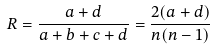Convert formula to latex. <formula><loc_0><loc_0><loc_500><loc_500>R = \frac { a + d } { a + b + c + d } = \frac { 2 ( a + d ) } { n ( n - 1 ) }</formula> 